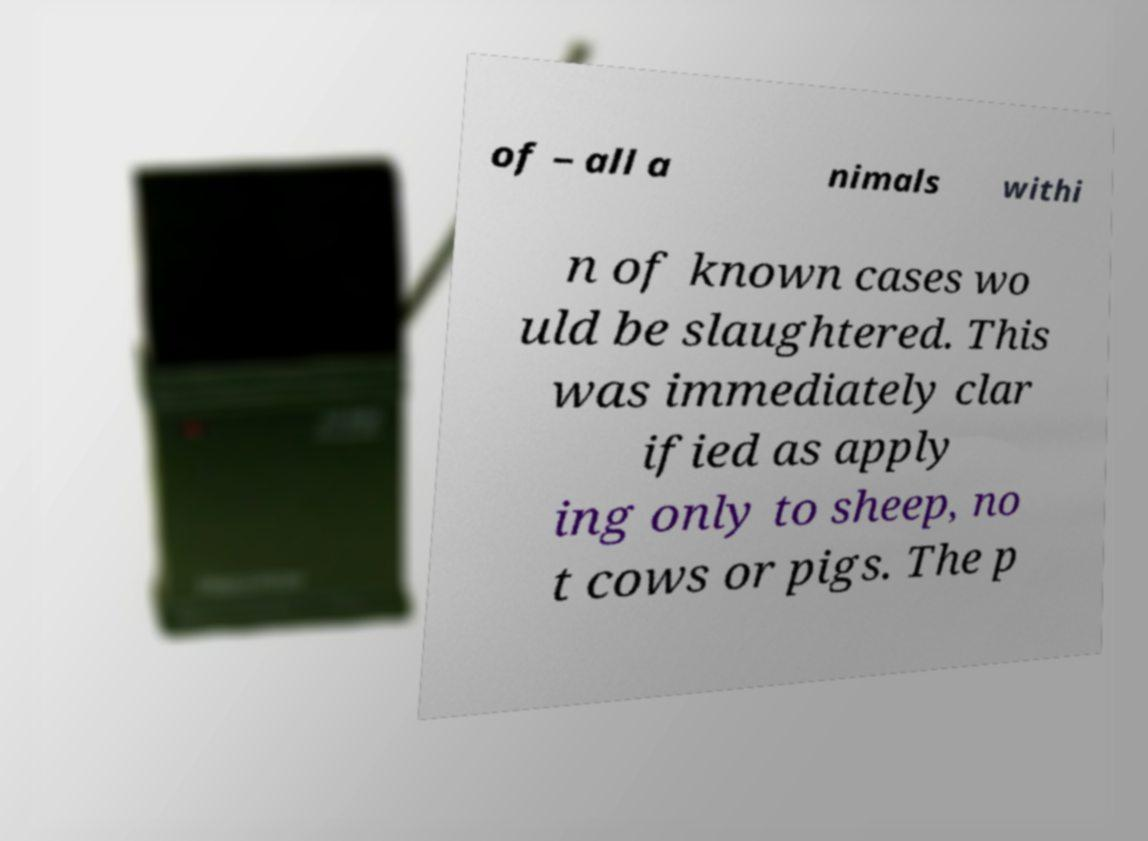Can you read and provide the text displayed in the image?This photo seems to have some interesting text. Can you extract and type it out for me? of – all a nimals withi n of known cases wo uld be slaughtered. This was immediately clar ified as apply ing only to sheep, no t cows or pigs. The p 